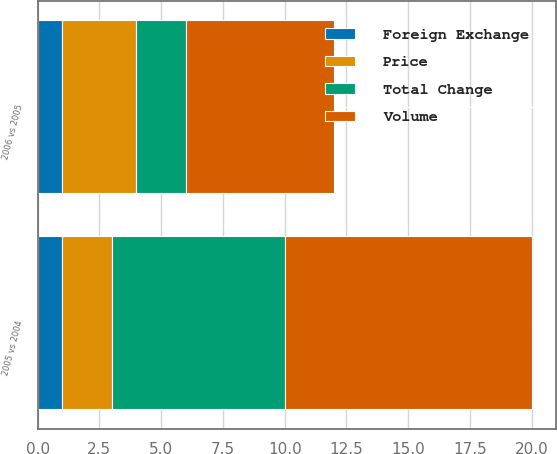Convert chart. <chart><loc_0><loc_0><loc_500><loc_500><stacked_bar_chart><ecel><fcel>2006 vs 2005<fcel>2005 vs 2004<nl><fcel>Volume<fcel>6<fcel>10<nl><fcel>Total Change<fcel>2<fcel>7<nl><fcel>Price<fcel>3<fcel>2<nl><fcel>Foreign Exchange<fcel>1<fcel>1<nl></chart> 